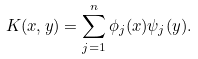<formula> <loc_0><loc_0><loc_500><loc_500>K ( x , y ) = \sum _ { j = 1 } ^ { n } \phi _ { j } ( x ) \psi _ { j } ( y ) .</formula> 